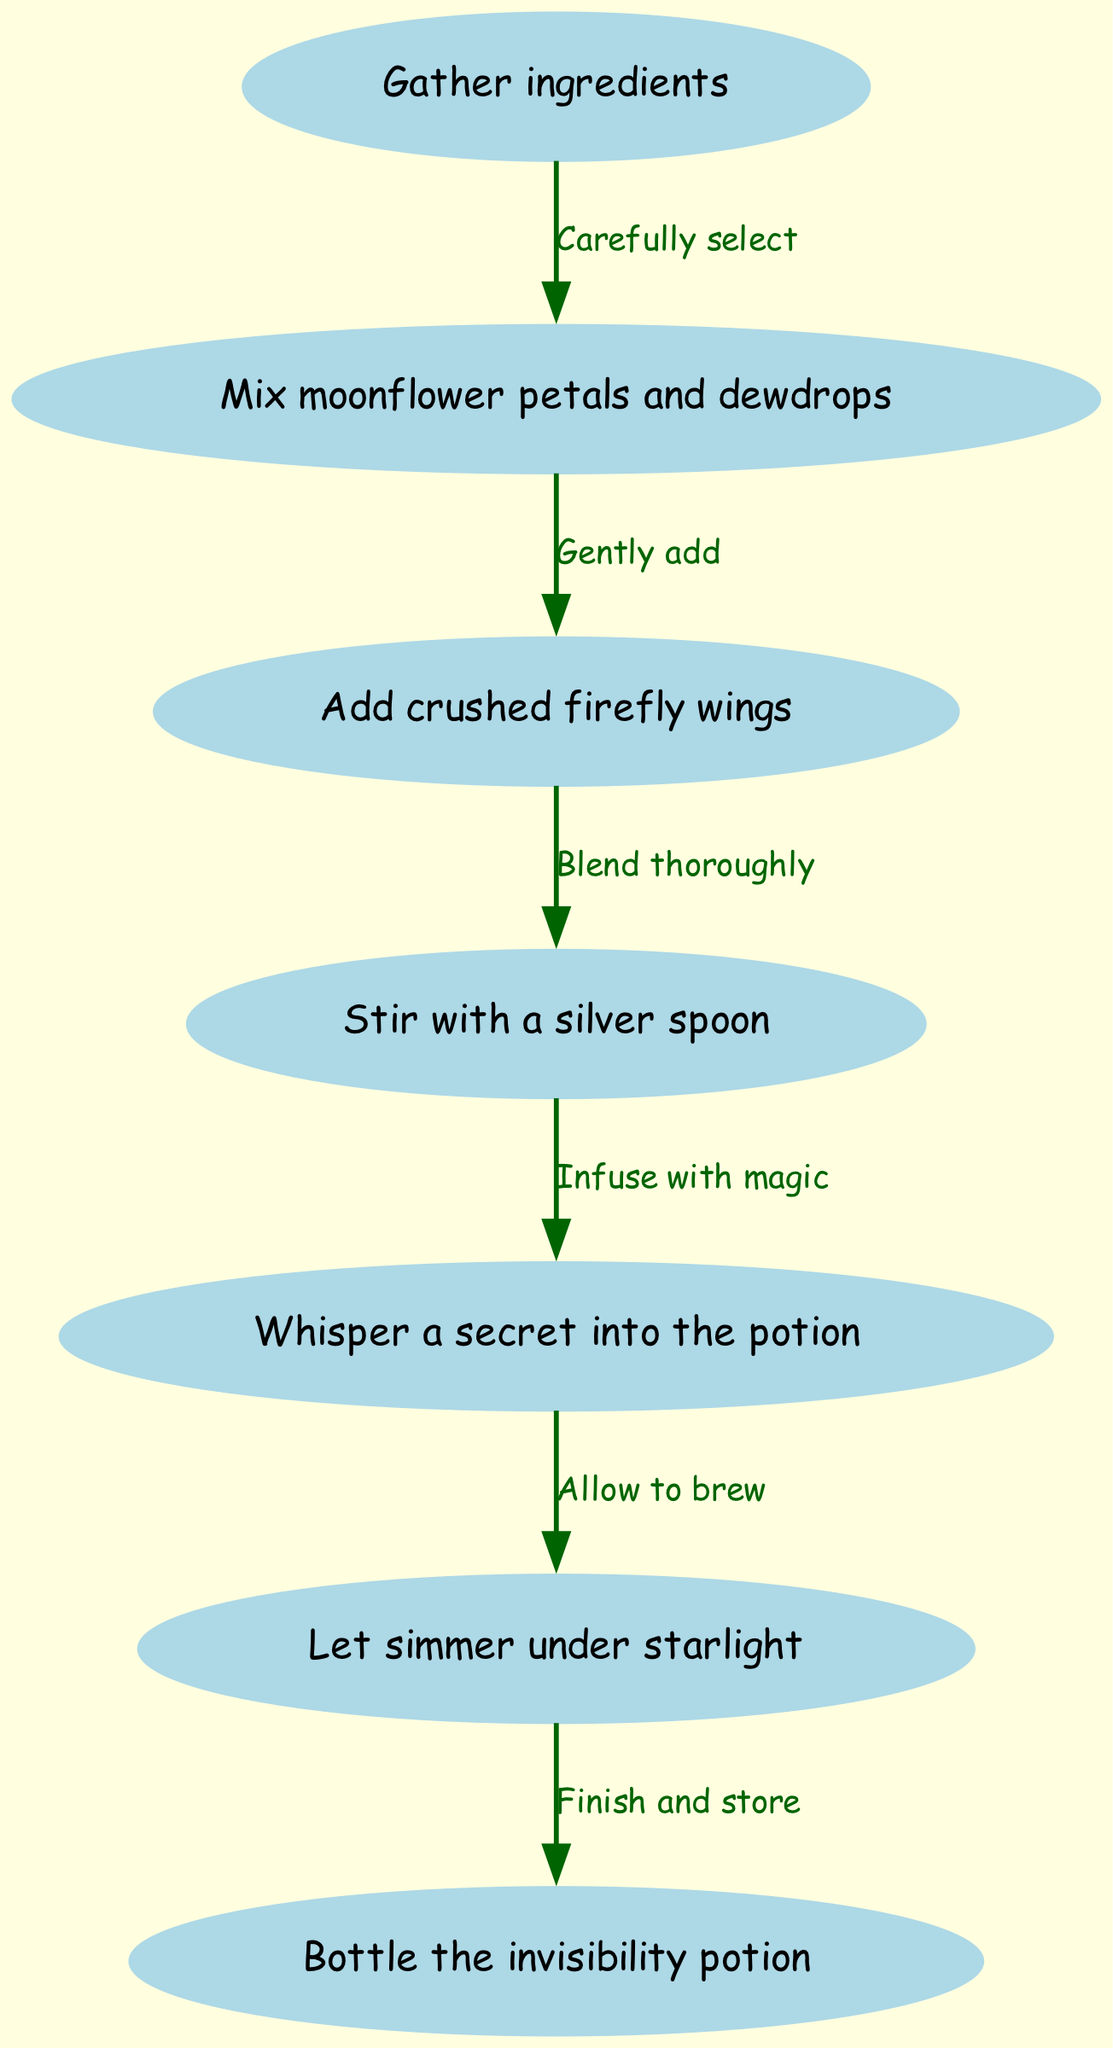What is the first step in brewing the potion? The first step in the diagram is "Gather ingredients," which is identified as node 1, and it is the starting point for brewing the potion.
Answer: Gather ingredients How many nodes are there in the diagram? By counting each unique step represented in the diagram, we find a total of 7 nodes, each corresponding to a specific action in the potion-brewing process.
Answer: 7 What is the last step before bottling the potion? The step before bottling the potion is "Let simmer under starlight," which is connected to the bottling step, identifying it as a vital precursor to storing the potion.
Answer: Let simmer under starlight What should you do after mixing moonflower petals and dewdrops? After mixing moonflower petals and dewdrops, the next action is adding crushed firefly wings, which is explicitly stated in the directional flow of the diagram between nodes 2 and 3.
Answer: Add crushed firefly wings What action is taken before whispering a secret into the potion? Prior to whispering a secret into the potion, you must stir with a silver spoon, which is indicated as connected to the whispering phase in the sequence of potion-making steps.
Answer: Stir with a silver spoon Which ingredient comes after crushed firefly wings? The ingredient that comes after crushed firefly wings is "Stir with a silver spoon," which follows as the next necessary step in the potion-brewing process as shown in the diagram.
Answer: Stir with a silver spoon What is required before letting the potion simmer? Before allowing the potion to simmer, you must whisper a secret into it, which shows the magical element necessary for completing the brewing process as indicated in the flow sequence.
Answer: Whisper a secret into the potion What connects letting the potion simmer to bottling it? The connection is "Finish and store," which indicates the final action taken before the potion can be bottled, thereby completing the process.
Answer: Finish and store 